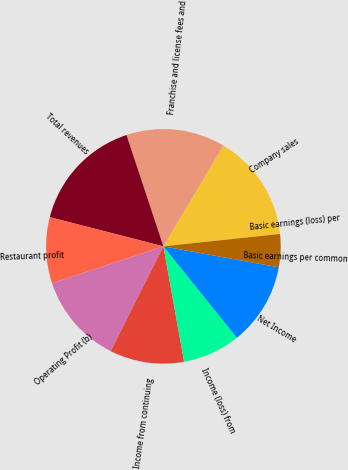<chart> <loc_0><loc_0><loc_500><loc_500><pie_chart><fcel>Company sales<fcel>Franchise and license fees and<fcel>Total revenues<fcel>Restaurant profit<fcel>Operating Profit (b)<fcel>Income from continuing<fcel>Income (loss) from<fcel>Net Income<fcel>Basic earnings per common<fcel>Basic earnings (loss) per<nl><fcel>14.77%<fcel>13.64%<fcel>15.91%<fcel>9.09%<fcel>12.5%<fcel>10.23%<fcel>7.95%<fcel>11.36%<fcel>4.55%<fcel>0.0%<nl></chart> 